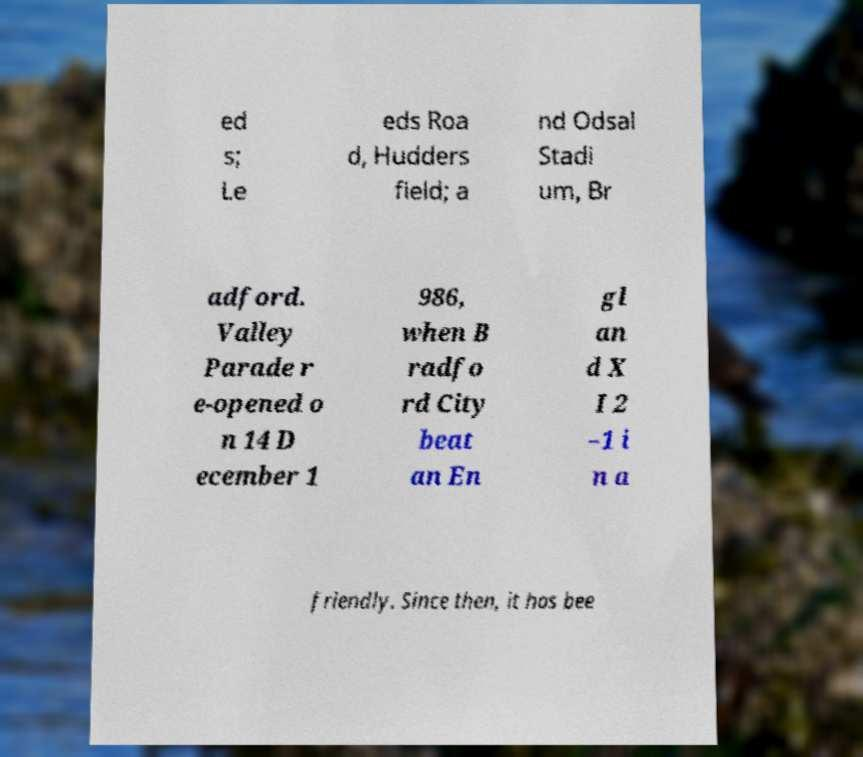Please identify and transcribe the text found in this image. ed s; Le eds Roa d, Hudders field; a nd Odsal Stadi um, Br adford. Valley Parade r e-opened o n 14 D ecember 1 986, when B radfo rd City beat an En gl an d X I 2 –1 i n a friendly. Since then, it has bee 